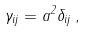<formula> <loc_0><loc_0><loc_500><loc_500>\gamma _ { i j } = a ^ { 2 } \delta _ { i j } \, ,</formula> 